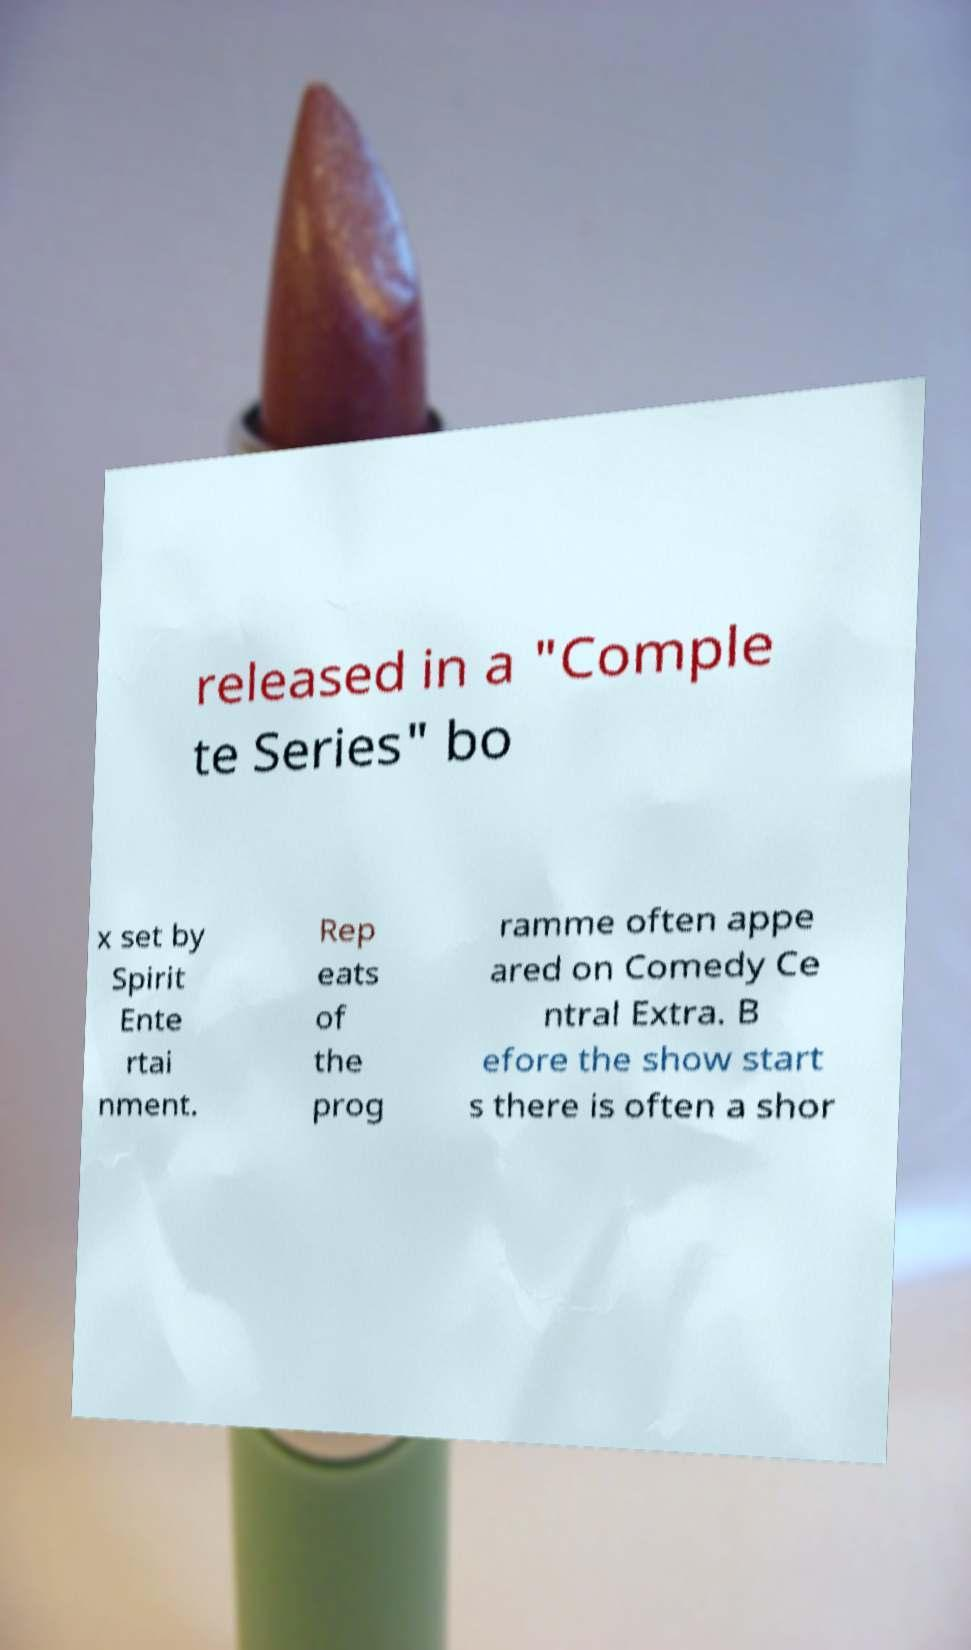For documentation purposes, I need the text within this image transcribed. Could you provide that? released in a "Comple te Series" bo x set by Spirit Ente rtai nment. Rep eats of the prog ramme often appe ared on Comedy Ce ntral Extra. B efore the show start s there is often a shor 